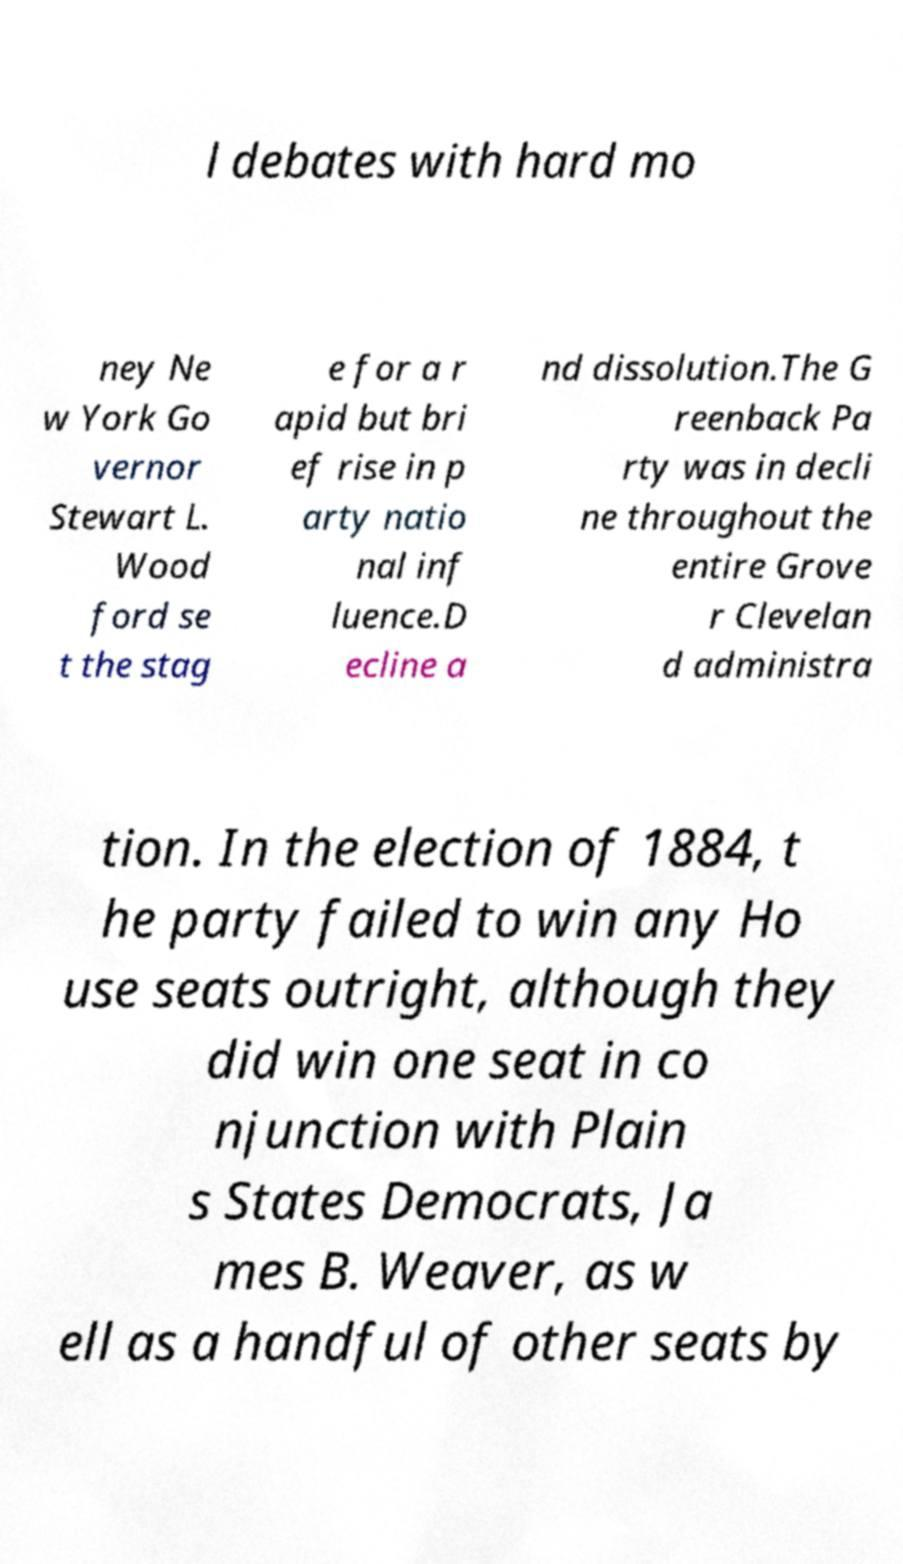Please identify and transcribe the text found in this image. l debates with hard mo ney Ne w York Go vernor Stewart L. Wood ford se t the stag e for a r apid but bri ef rise in p arty natio nal inf luence.D ecline a nd dissolution.The G reenback Pa rty was in decli ne throughout the entire Grove r Clevelan d administra tion. In the election of 1884, t he party failed to win any Ho use seats outright, although they did win one seat in co njunction with Plain s States Democrats, Ja mes B. Weaver, as w ell as a handful of other seats by 